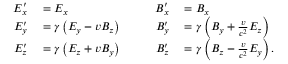<formula> <loc_0><loc_0><loc_500><loc_500>\begin{array} { r l r l } { E _ { x } ^ { \prime } } & = E _ { x } } & { \quad B _ { x } ^ { \prime } } & = B _ { x } } \\ { E _ { y } ^ { \prime } } & = \gamma \left ( E _ { y } - v B _ { z } \right ) } & { B _ { y } ^ { \prime } } & = \gamma \left ( B _ { y } + { \frac { v } { c ^ { 2 } } } E _ { z } \right ) } \\ { E _ { z } ^ { \prime } } & = \gamma \left ( E _ { z } + v B _ { y } \right ) } & { B _ { z } ^ { \prime } } & = \gamma \left ( B _ { z } - { \frac { v } { c ^ { 2 } } } E _ { y } \right ) . } \end{array}</formula> 